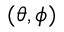Convert formula to latex. <formula><loc_0><loc_0><loc_500><loc_500>( \theta , \phi )</formula> 